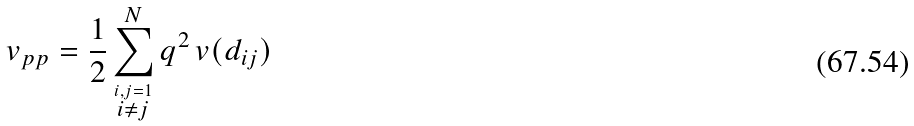<formula> <loc_0><loc_0><loc_500><loc_500>v _ { p p } = \frac { 1 } { 2 } \sum _ { \stackrel { i , j = 1 } { i \neq j } } ^ { N } q ^ { 2 } \, v ( d _ { i j } )</formula> 